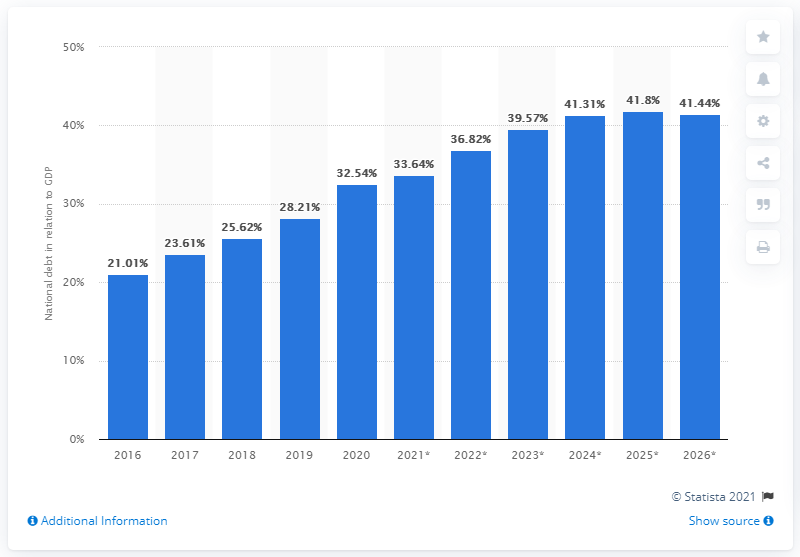What projections can be seen on the graph for Chile's national debt after 2020, and how reliable might these be? The graph provides projections for the national debt as a percentage of GDP from 2021 up to 2026, showing a continuous upward trajectory reaching as high as 41.4% by 2026. It's important to note that these are projections and might not fully account for future economic conditions, policy changes, or unexpected events. As such, while they can offer a potential trend outlook, actual figures may vary, and the reliability of these forecasts depends on the underlying assumptions and models used to generate them. 